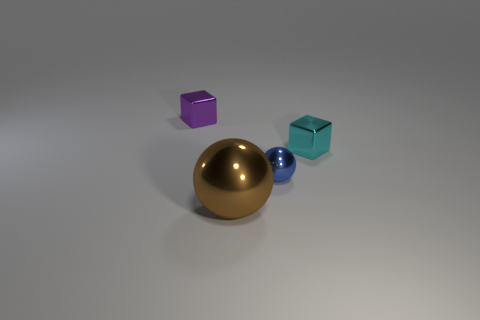Do the tiny metal cube that is to the left of the cyan shiny block and the tiny metallic thing that is in front of the cyan metallic cube have the same color?
Ensure brevity in your answer.  No. What is the shape of the tiny cyan thing?
Keep it short and to the point. Cube. How many big brown metal things are behind the brown ball?
Offer a very short reply. 0. How many large things are the same material as the cyan block?
Provide a short and direct response. 1. Are the small cube to the left of the brown metal thing and the tiny blue thing made of the same material?
Offer a very short reply. Yes. Is there a big brown thing?
Make the answer very short. Yes. How big is the metallic thing that is both to the right of the big brown metallic thing and behind the blue metal sphere?
Give a very brief answer. Small. Is the number of metal blocks that are behind the small cyan thing greater than the number of big brown shiny objects that are on the right side of the large brown object?
Ensure brevity in your answer.  Yes. What color is the large metal object?
Your answer should be very brief. Brown. What is the color of the small object that is both behind the tiny blue metallic sphere and to the right of the brown metallic sphere?
Offer a very short reply. Cyan. 